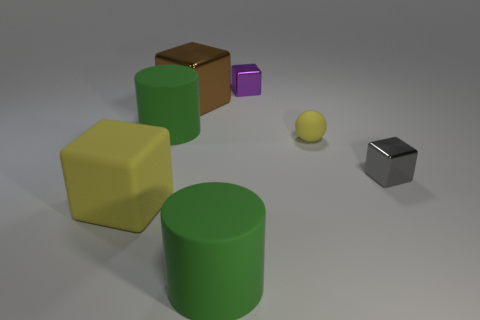Subtract 2 blocks. How many blocks are left? 2 Add 2 tiny metal cylinders. How many objects exist? 9 Subtract all blue blocks. Subtract all purple balls. How many blocks are left? 4 Subtract all blocks. How many objects are left? 3 Add 5 spheres. How many spheres exist? 6 Subtract 0 red cylinders. How many objects are left? 7 Subtract all big green rubber cylinders. Subtract all purple shiny blocks. How many objects are left? 4 Add 3 purple metallic blocks. How many purple metallic blocks are left? 4 